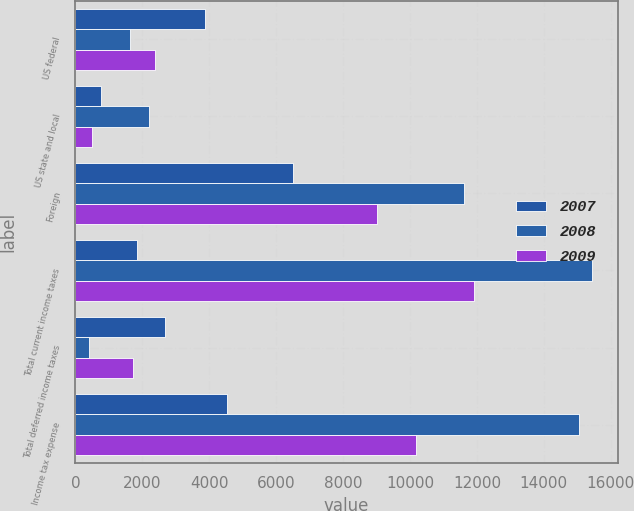Convert chart. <chart><loc_0><loc_0><loc_500><loc_500><stacked_bar_chart><ecel><fcel>US federal<fcel>US state and local<fcel>Foreign<fcel>Total current income taxes<fcel>Total deferred income taxes<fcel>Income tax expense<nl><fcel>2007<fcel>3871<fcel>779<fcel>6504<fcel>1854<fcel>2667<fcel>4521<nl><fcel>2008<fcel>1624<fcel>2197<fcel>11616<fcel>15437<fcel>391<fcel>15046<nl><fcel>2009<fcel>2390<fcel>491<fcel>9028<fcel>11909<fcel>1718<fcel>10191<nl></chart> 